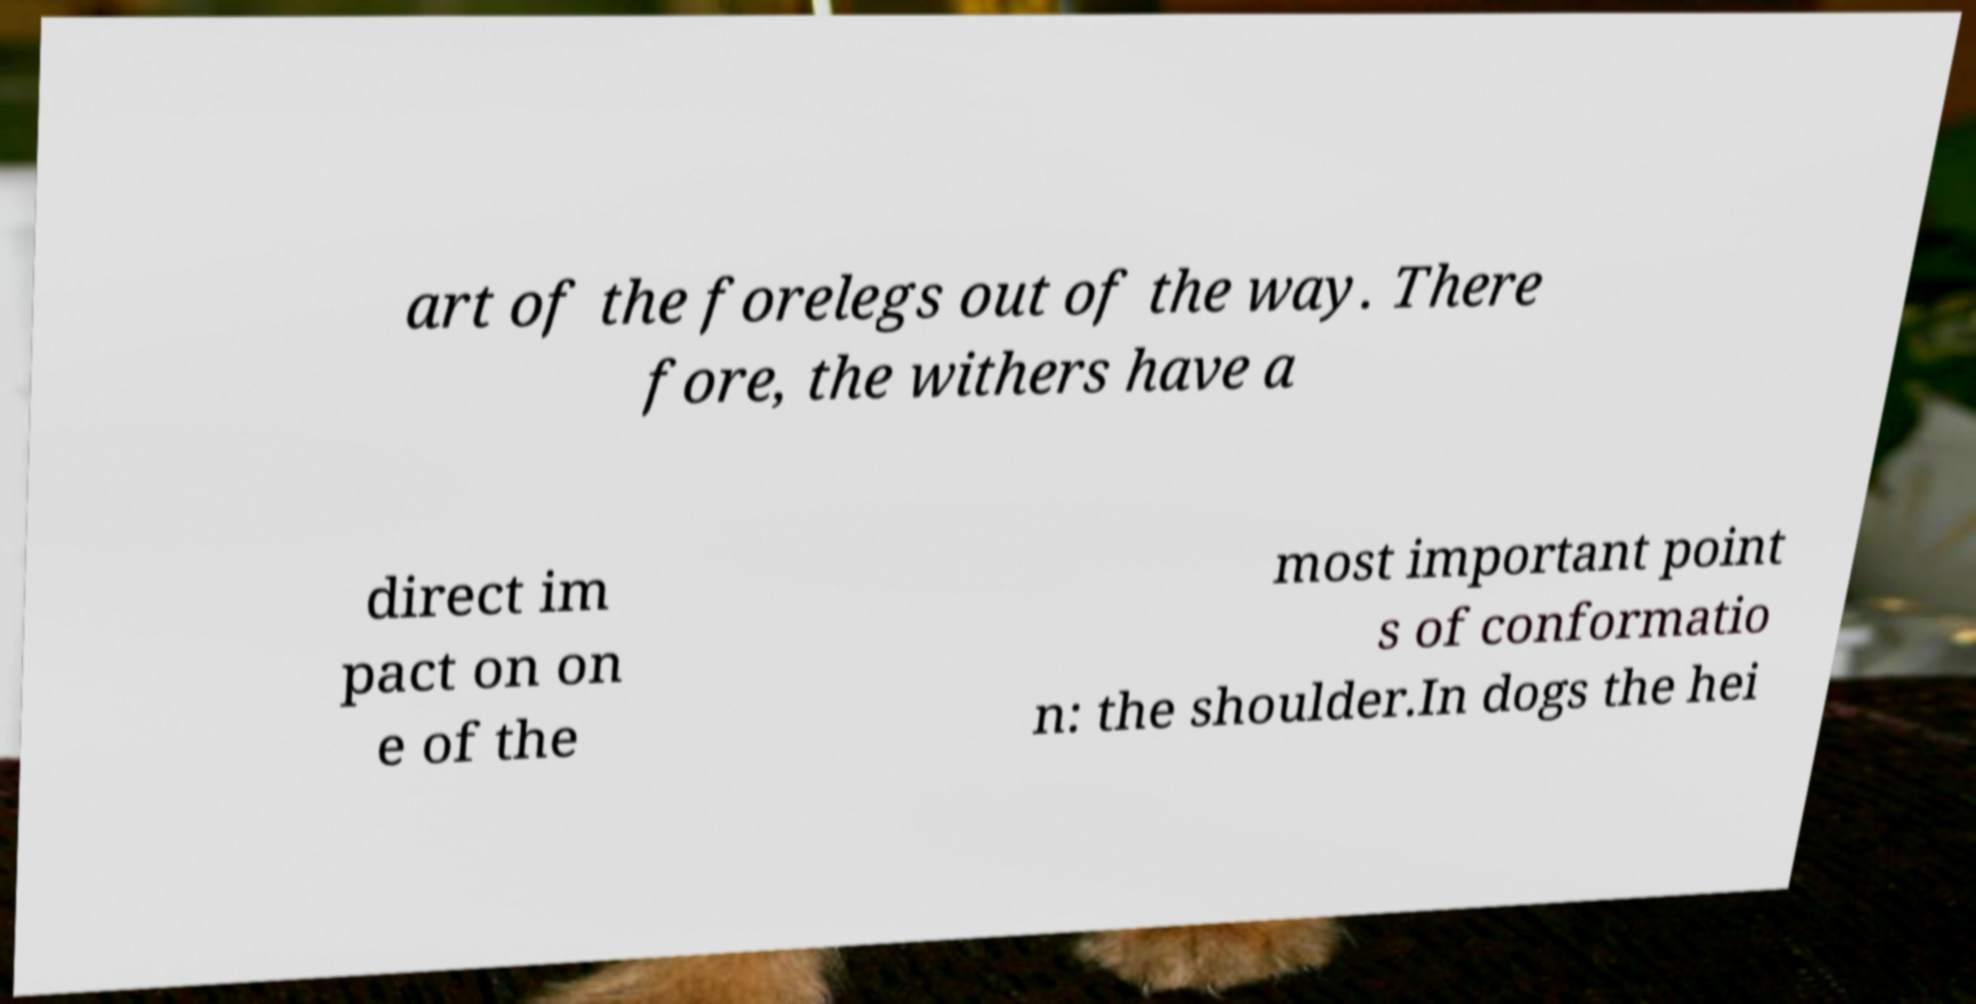For documentation purposes, I need the text within this image transcribed. Could you provide that? art of the forelegs out of the way. There fore, the withers have a direct im pact on on e of the most important point s of conformatio n: the shoulder.In dogs the hei 